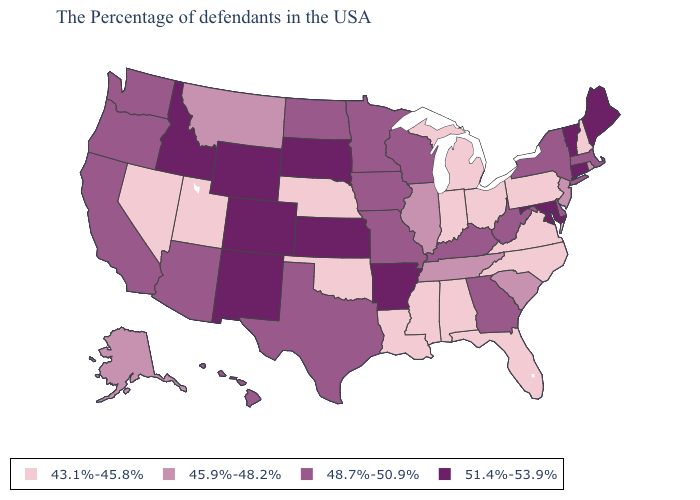Name the states that have a value in the range 51.4%-53.9%?
Write a very short answer. Maine, Vermont, Connecticut, Maryland, Arkansas, Kansas, South Dakota, Wyoming, Colorado, New Mexico, Idaho. What is the value of Connecticut?
Write a very short answer. 51.4%-53.9%. Does Oklahoma have a lower value than Rhode Island?
Quick response, please. Yes. Does the map have missing data?
Keep it brief. No. What is the highest value in the Northeast ?
Keep it brief. 51.4%-53.9%. Is the legend a continuous bar?
Be succinct. No. What is the value of Montana?
Quick response, please. 45.9%-48.2%. Name the states that have a value in the range 51.4%-53.9%?
Write a very short answer. Maine, Vermont, Connecticut, Maryland, Arkansas, Kansas, South Dakota, Wyoming, Colorado, New Mexico, Idaho. Among the states that border Delaware , does Pennsylvania have the highest value?
Quick response, please. No. Does Illinois have the lowest value in the MidWest?
Quick response, please. No. Which states have the highest value in the USA?
Give a very brief answer. Maine, Vermont, Connecticut, Maryland, Arkansas, Kansas, South Dakota, Wyoming, Colorado, New Mexico, Idaho. Among the states that border Wisconsin , which have the lowest value?
Concise answer only. Michigan. Which states have the highest value in the USA?
Answer briefly. Maine, Vermont, Connecticut, Maryland, Arkansas, Kansas, South Dakota, Wyoming, Colorado, New Mexico, Idaho. Does Maryland have the highest value in the USA?
Short answer required. Yes. What is the lowest value in states that border Connecticut?
Concise answer only. 45.9%-48.2%. 